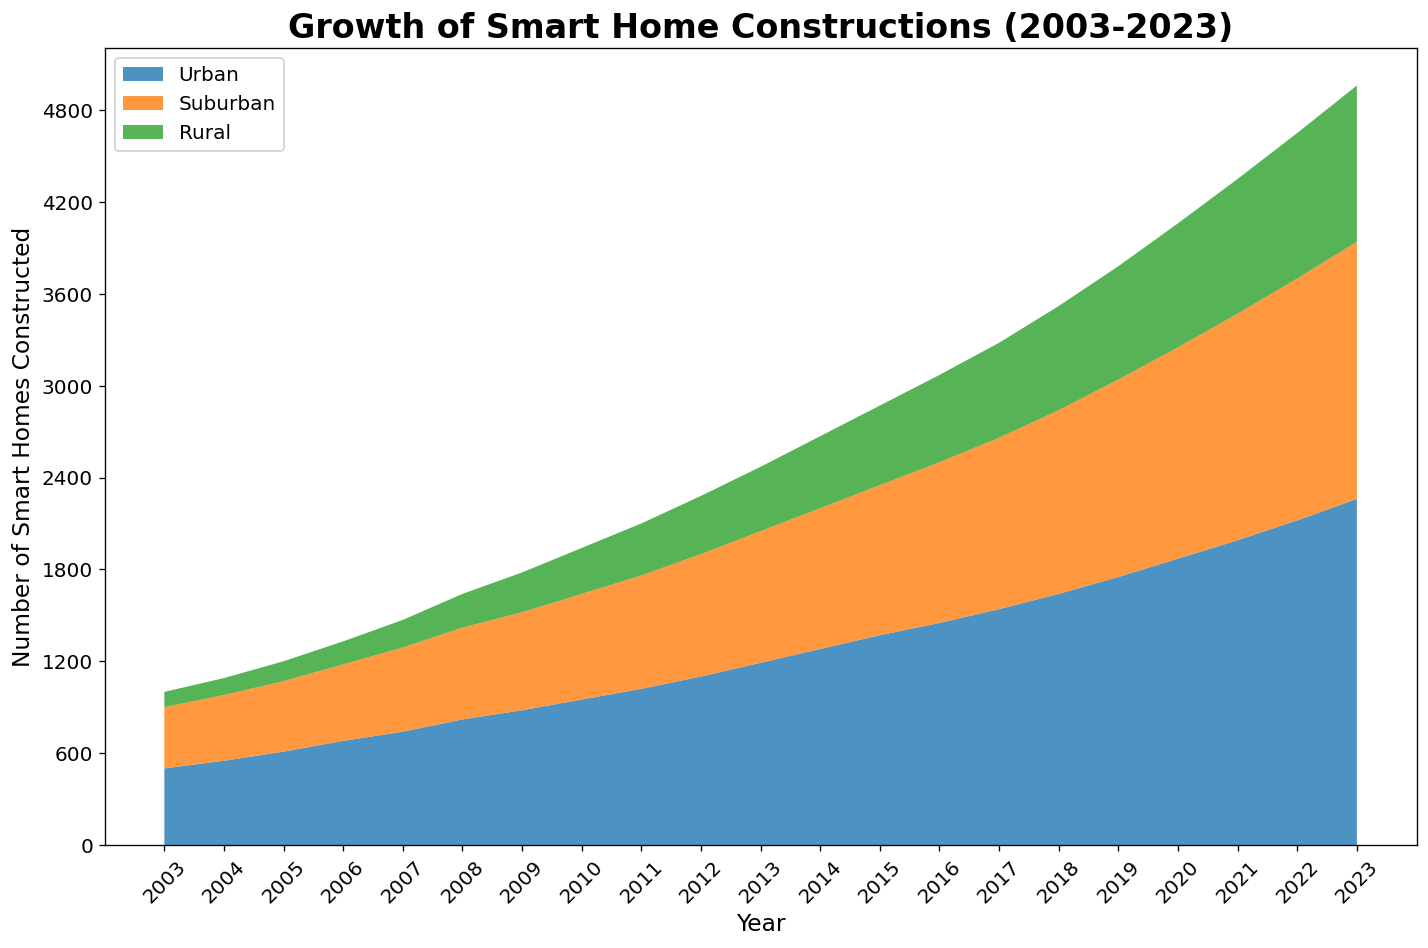What is the total number of smart homes constructed in urban areas over the period shown in the figure? Add all the values for urban constructions from 2003 to 2023: 500 + 550 + 610 + 680 + 740 + 820 + 880 + 950 + 1020 + 1100 + 1190 + 1280 + 1370 + 1450 + 1540 + 1640 + 1750 + 1870 + 1990 + 2120 + 2260 = 28210
Answer: 28210 In which year did rural areas see smart home constructions surpass 500 units? Look for the year when the rural construction data surpasses 500 units. The values before 2017 are below 500 and in 2017 it reaches 570. Therefore, 2017 is the year when rural constructions first surpass 500 units.
Answer: 2017 How do the number of smart home constructions in urban areas in 2023 compare to the total number in suburban areas in 2020 and 2023 combined? Urban constructions in 2023 are 2260. Add the suburban constructions in 2020 and 2023: 1380 + 1680 = 3060. Compare the two: 2260 (urban 2023) < 3060 (suburban 2020 and 2023 combined).
Answer: Less Which area saw the fastest growth in smart home constructions from 2019 to 2023? Calculate the growth for each area by subtracting the 2019 values from the 2023 values. Urban: 2260 - 1750 = 510, Suburban: 1680 - 1290 = 390, Rural: 1020 - 740 = 280. Urban growth of 510 is the highest.
Answer: Urban In which year did suburban constructions first surpass urban constructions for that year? Compare year-by-year data for suburban and urban constructions. Urban constructions are consistently higher each year. Therefore, suburban constructions never surpassed urban during the given period.
Answer: Never By how much did smart home constructions in rural areas lag behind suburban areas in 2015? Suburban: 980, Rural: 520 in 2015. The difference is 980 - 520 = 460.
Answer: 460 What is the difference between the maximum number of smart home constructions in urban areas and the minimum number in rural areas over the period? Maximum urban constructions: 2260 in 2023. Minimum rural constructions: 100 in 2003. The difference is 2260 - 100 = 2160.
Answer: 2160 Estimate the overall visual trend for smart homes in rural areas. Are they generally increasing, decreasing, or remaining stable? By observing the area chart, the rural constructions show a consistent upward trend from 2003 to 2023, indicating an overall increase.
Answer: Increasing Which area saw relatively uniform year-over-year increase in smart home constructions? By looking at the figure, urban and suburban areas show relatively smooth and consistent incremental increases each year, whereas rural areas show some noticeable variations.
Answer: Urban and Suburban How does the increase in smart home constructions in the suburban area from 2008 to 2013 compare to that in the rural area over the same period? Suburban increase: 860 (2013) - 600 (2008) = 260. Rural increase: 420 (2013) - 220 (2008) = 200. Compare the two increments, 260 > 200.
Answer: Greater in Suburban 